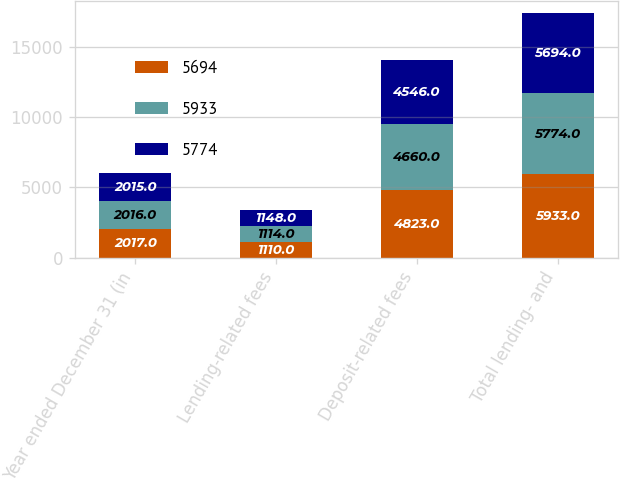<chart> <loc_0><loc_0><loc_500><loc_500><stacked_bar_chart><ecel><fcel>Year ended December 31 (in<fcel>Lending-related fees<fcel>Deposit-related fees<fcel>Total lending- and<nl><fcel>5694<fcel>2017<fcel>1110<fcel>4823<fcel>5933<nl><fcel>5933<fcel>2016<fcel>1114<fcel>4660<fcel>5774<nl><fcel>5774<fcel>2015<fcel>1148<fcel>4546<fcel>5694<nl></chart> 